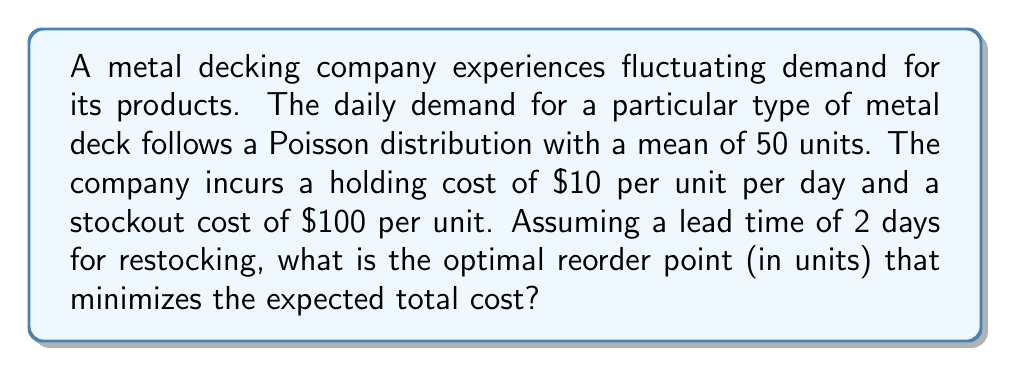Provide a solution to this math problem. To solve this problem, we'll use the newsvendor model, which is applicable for stochastic demand scenarios. The optimal reorder point is determined by finding the critical fractile.

Step 1: Calculate the critical fractile (CF)
$$ CF = \frac{c_u}{c_u + c_o} $$
where $c_u$ is the underage cost (stockout cost) and $c_o$ is the overage cost (holding cost).

$$ CF = \frac{100}{100 + 10} = \frac{100}{110} \approx 0.9091 $$

Step 2: Determine the demand distribution over the lead time
Since the demand follows a Poisson distribution with a daily mean of 50 units, and the lead time is 2 days, the demand during lead time follows a Poisson distribution with mean:
$$ \lambda = 50 \times 2 = 100 $$

Step 3: Find the optimal reorder point
We need to find the smallest value of x such that:
$$ P(X \leq x) \geq 0.9091 $$
where X is the Poisson-distributed random variable with $\lambda = 100$.

Using a Poisson distribution table or calculator, we find that:
$$ P(X \leq 115) = 0.9041 $$
$$ P(X \leq 116) = 0.9168 $$

Therefore, the optimal reorder point is 116 units, as it's the smallest value that satisfies the condition.
Answer: 116 units 